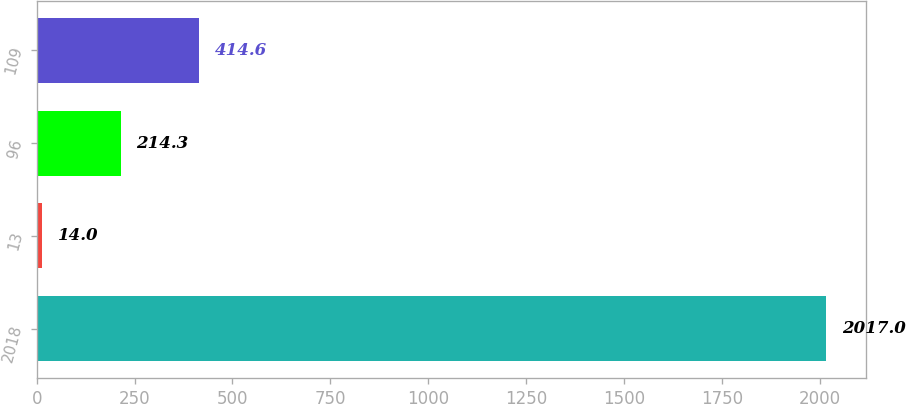Convert chart. <chart><loc_0><loc_0><loc_500><loc_500><bar_chart><fcel>2018<fcel>13<fcel>96<fcel>109<nl><fcel>2017<fcel>14<fcel>214.3<fcel>414.6<nl></chart> 